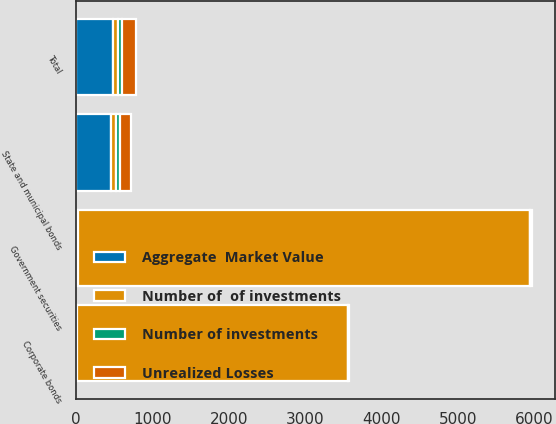Convert chart. <chart><loc_0><loc_0><loc_500><loc_500><stacked_bar_chart><ecel><fcel>Government securities<fcel>State and municipal bonds<fcel>Corporate bonds<fcel>Total<nl><fcel>Number of investments<fcel>1<fcel>57<fcel>4<fcel>62<nl><fcel>Number of  of investments<fcel>5921<fcel>59.5<fcel>3555<fcel>59.5<nl><fcel>Aggregate  Market Value<fcel>21<fcel>458<fcel>5<fcel>484<nl><fcel>Unrealized Losses<fcel>30<fcel>138<fcel>5<fcel>173<nl></chart> 